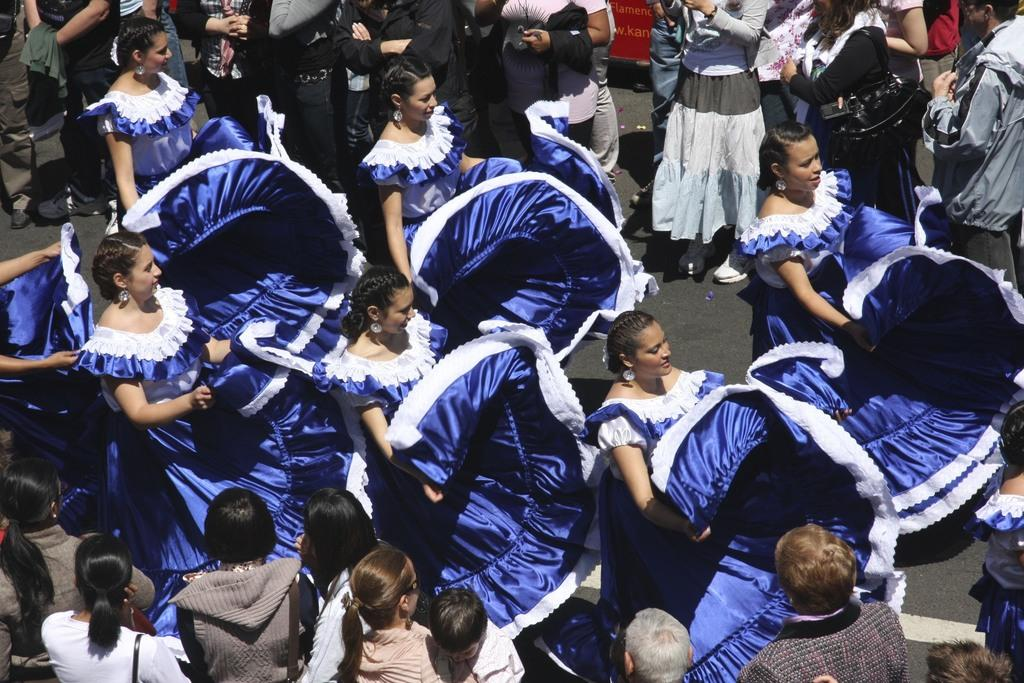What are the people in the image wearing? The people in the image are wearing costumes. What can be seen in the background of the image? There is a board in the background of the image. What type of shoes are the pets wearing in the image? There are no pets or shoes present in the image. What can be seen between the teeth of the people in the image? There are no teeth visible in the image, as the people are wearing costumes that cover their faces. 